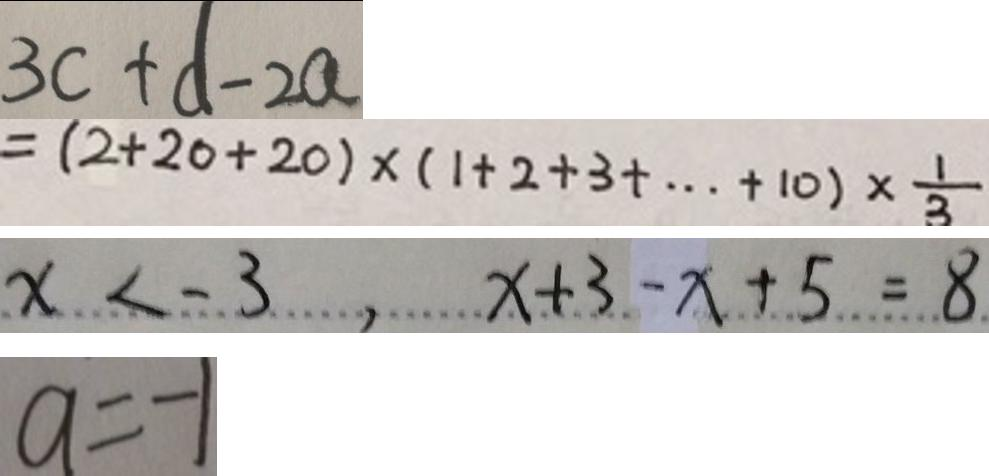Convert formula to latex. <formula><loc_0><loc_0><loc_500><loc_500>3 c + d - 2 a 
 = ( 2 + 2 0 + 2 0 ) \times ( 1 + 2 + 3 + \cdots + 1 0 ) \times \frac { 1 } { 3 } 
 x < - 3 , x + 3 - x + 5 = 8 
 a = - 1</formula> 